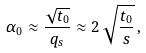<formula> <loc_0><loc_0><loc_500><loc_500>\alpha _ { 0 } \approx \frac { \sqrt { t _ { 0 } } } { q _ { s } } \approx 2 \, \sqrt { \frac { t _ { 0 } } { s } } \, ,</formula> 